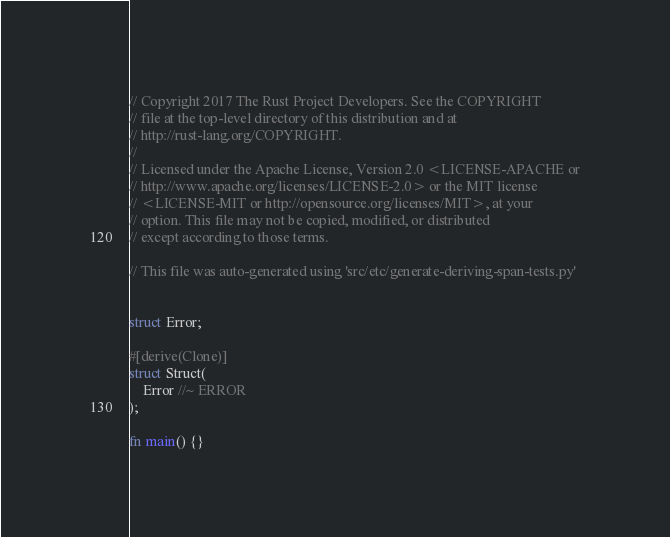<code> <loc_0><loc_0><loc_500><loc_500><_Rust_>// Copyright 2017 The Rust Project Developers. See the COPYRIGHT
// file at the top-level directory of this distribution and at
// http://rust-lang.org/COPYRIGHT.
//
// Licensed under the Apache License, Version 2.0 <LICENSE-APACHE or
// http://www.apache.org/licenses/LICENSE-2.0> or the MIT license
// <LICENSE-MIT or http://opensource.org/licenses/MIT>, at your
// option. This file may not be copied, modified, or distributed
// except according to those terms.

// This file was auto-generated using 'src/etc/generate-deriving-span-tests.py'


struct Error;

#[derive(Clone)]
struct Struct(
    Error //~ ERROR
);

fn main() {}
</code> 